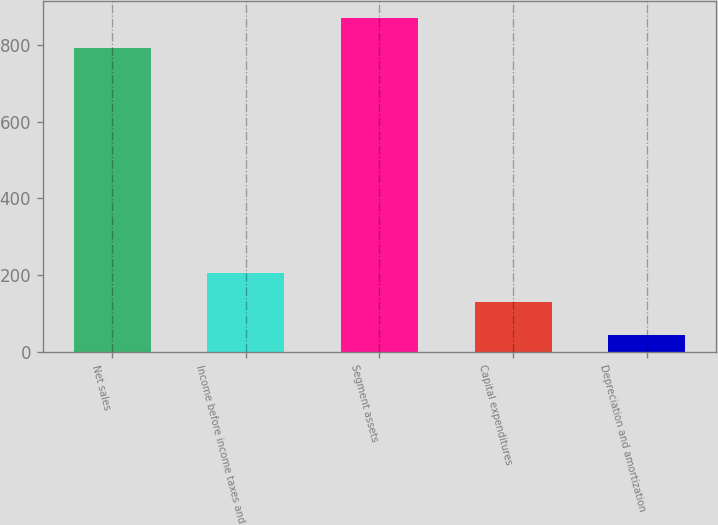Convert chart to OTSL. <chart><loc_0><loc_0><loc_500><loc_500><bar_chart><fcel>Net sales<fcel>Income before income taxes and<fcel>Segment assets<fcel>Capital expenditures<fcel>Depreciation and amortization<nl><fcel>792.1<fcel>206.44<fcel>869.34<fcel>129.2<fcel>43.9<nl></chart> 